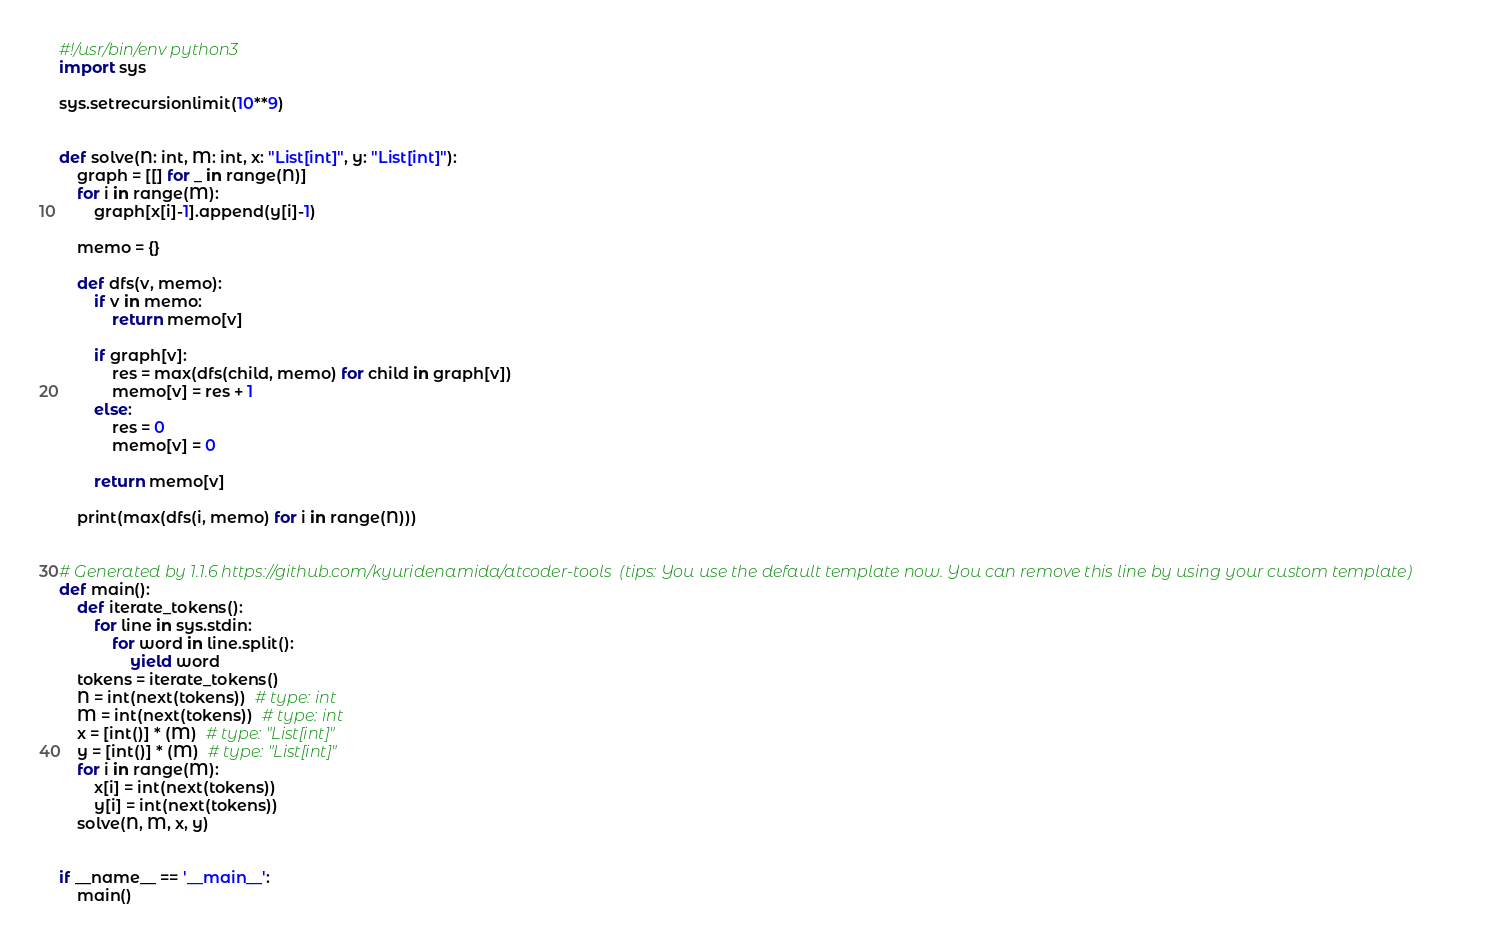Convert code to text. <code><loc_0><loc_0><loc_500><loc_500><_Python_>#!/usr/bin/env python3
import sys

sys.setrecursionlimit(10**9)


def solve(N: int, M: int, x: "List[int]", y: "List[int]"):
    graph = [[] for _ in range(N)]
    for i in range(M):
        graph[x[i]-1].append(y[i]-1)

    memo = {}

    def dfs(v, memo):
        if v in memo:
            return memo[v]

        if graph[v]:
            res = max(dfs(child, memo) for child in graph[v])
            memo[v] = res + 1
        else:
            res = 0
            memo[v] = 0

        return memo[v]

    print(max(dfs(i, memo) for i in range(N)))


# Generated by 1.1.6 https://github.com/kyuridenamida/atcoder-tools  (tips: You use the default template now. You can remove this line by using your custom template)
def main():
    def iterate_tokens():
        for line in sys.stdin:
            for word in line.split():
                yield word
    tokens = iterate_tokens()
    N = int(next(tokens))  # type: int
    M = int(next(tokens))  # type: int
    x = [int()] * (M)  # type: "List[int]"
    y = [int()] * (M)  # type: "List[int]"
    for i in range(M):
        x[i] = int(next(tokens))
        y[i] = int(next(tokens))
    solve(N, M, x, y)


if __name__ == '__main__':
    main()
</code> 